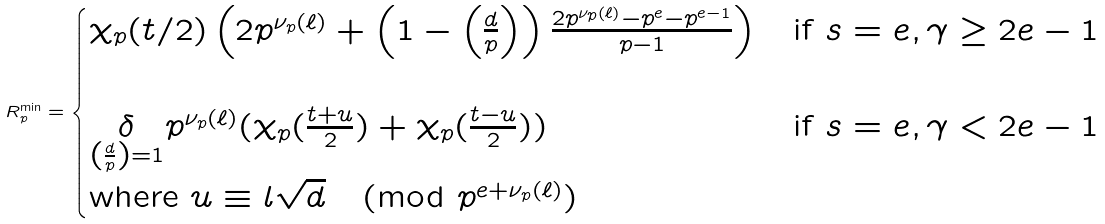<formula> <loc_0><loc_0><loc_500><loc_500>R _ { p } ^ { \min } = \begin{cases} \chi _ { p } ( t / 2 ) \left ( 2 p ^ { \nu _ { p } ( \ell ) } + \left ( 1 - \left ( \frac { d } { p } \right ) \right ) \frac { 2 p ^ { \nu _ { p } ( \ell ) } - p ^ { e } - p ^ { e - 1 } } { p - 1 } \right ) & \text {if } s = e , \gamma \geq 2 e - 1 \\ \\ \underset { \left ( \frac { d } { p } \right ) = 1 } { \delta } p ^ { \nu _ { p } ( \ell ) } ( \chi _ { p } ( \frac { t + u } { 2 } ) + \chi _ { p } ( \frac { t - u } { 2 } ) ) & \text {if } s = e , \gamma < 2 e - 1 \\ \text {where } u \equiv l \sqrt { d } \pmod { p ^ { e + \nu _ { p } ( \ell ) } } \\ \end{cases}</formula> 